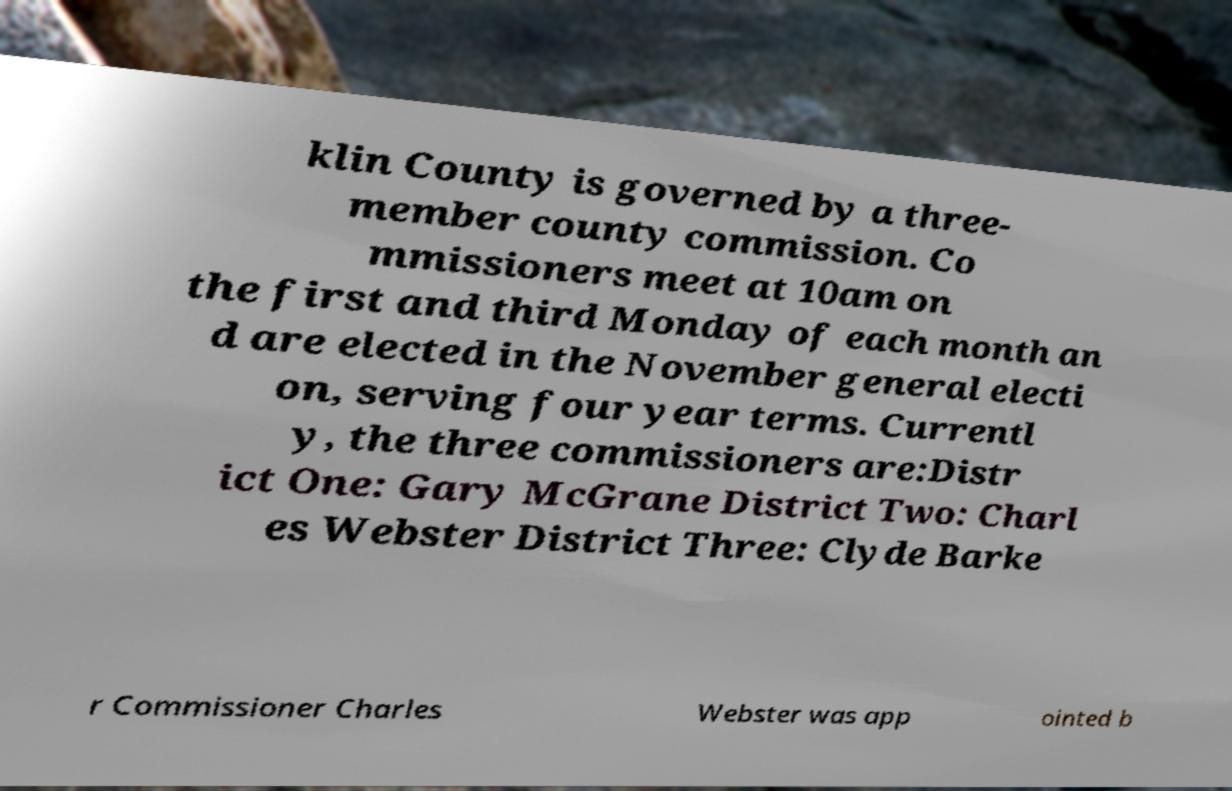Please read and relay the text visible in this image. What does it say? klin County is governed by a three- member county commission. Co mmissioners meet at 10am on the first and third Monday of each month an d are elected in the November general electi on, serving four year terms. Currentl y, the three commissioners are:Distr ict One: Gary McGrane District Two: Charl es Webster District Three: Clyde Barke r Commissioner Charles Webster was app ointed b 